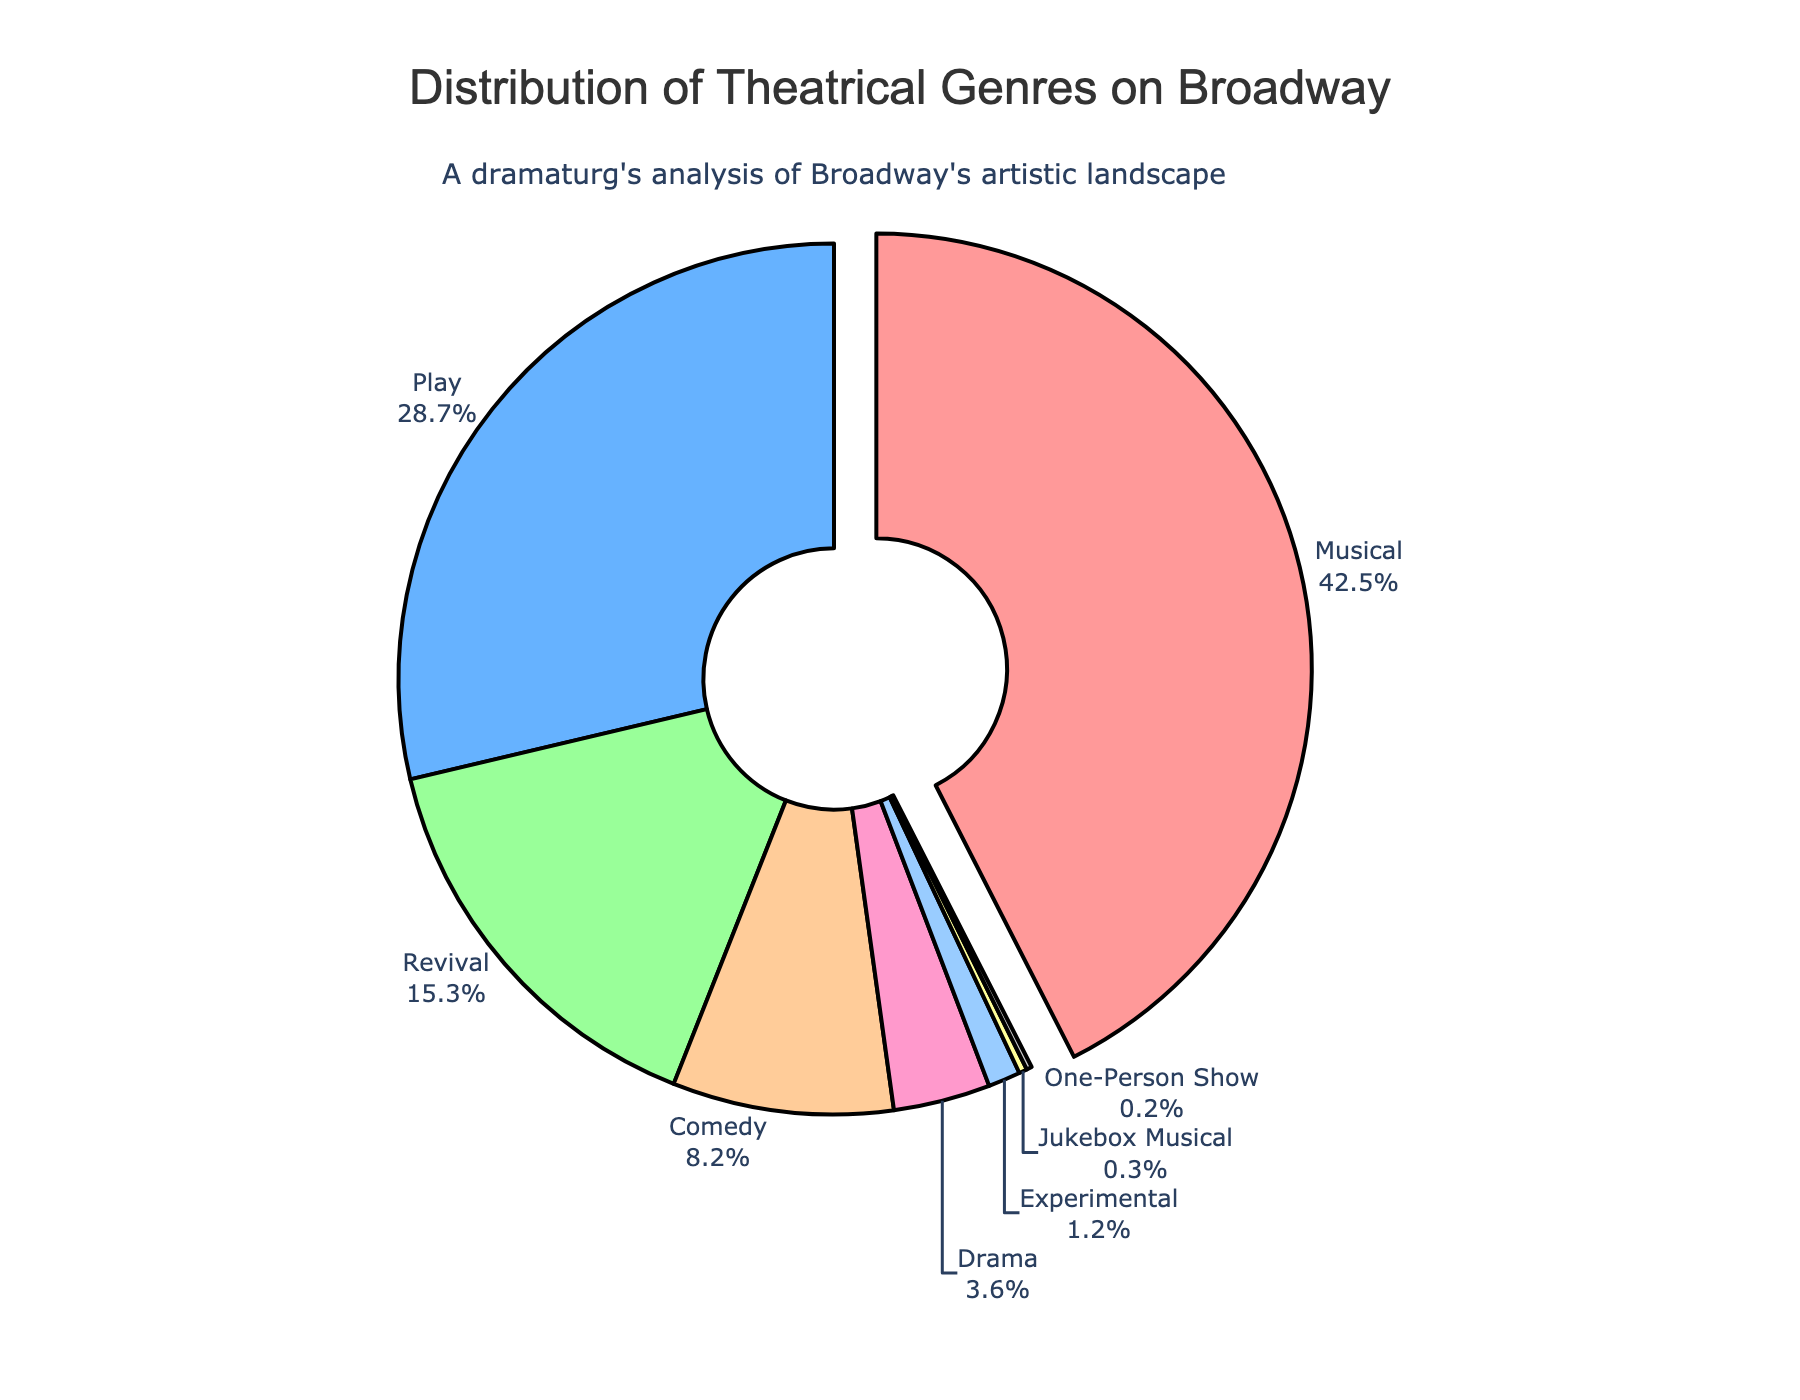What is the largest genre represented in the pie chart? The largest genre can be identified by its segment size and how it is pulled out slightly from the pie chart. Based on the visual and the percentage labeled, the largest segment is for Musicals, which is pulled out and shows 42.5%.
Answer: Musical How much larger is the percentage of Musicals compared to Plays? To find how much larger Musicals are compared to Plays, subtract the percentage of Plays from the percentage of Musicals: 42.5% - 28.7% = 13.8%.
Answer: 13.8% Which genres together make up exactly half of the total Broadway productions? Sum the percentages of genres until the total reaches or exceeds 50%. Adding Musicals (42.5%) and Plays (28.7%) gives us 71.2%, which already exceeds 50%. Hence, Musicals alone (42.5%) and the next genre, Plays (28.7%), ensure the total surpasses 50%.
Answer: Musicals and Plays What is the total percentage of genres other than Musicals and Plays? Subtract the combined percentage of Musicals and Plays from 100%: 100% - (42.5% + 28.7%) = 100% - 71.2% = 28.8%.
Answer: 28.8% Which genre has the smallest representation, and what is its percentage? Identify the segment with the smallest percentage in the chart. The smallest segment belongs to One-Person Show, labeled as 0.2%.
Answer: One-Person Show, 0.2% How do the percentages of Revival and Comedy compare? Compare the percentages directly from the pie chart. Revival is 15.3%, and Comedy is 8.2%, making Revival larger than Comedy by 15.3% - 8.2% = 7.1%.
Answer: Revival is 7.1% larger than Comedy What is the combined percentage of Drama and Experimental genres? Add the percentages of Drama and Experimental directly from the chart: 3.6% + 1.2% = 4.8%.
Answer: 4.8% Which genre is represented by the light pink color in the pie chart? Observe the color coding in the chart to identify the genre. The segment in light pink color corresponds to Revival, which shows 15.3%.
Answer: Revival 